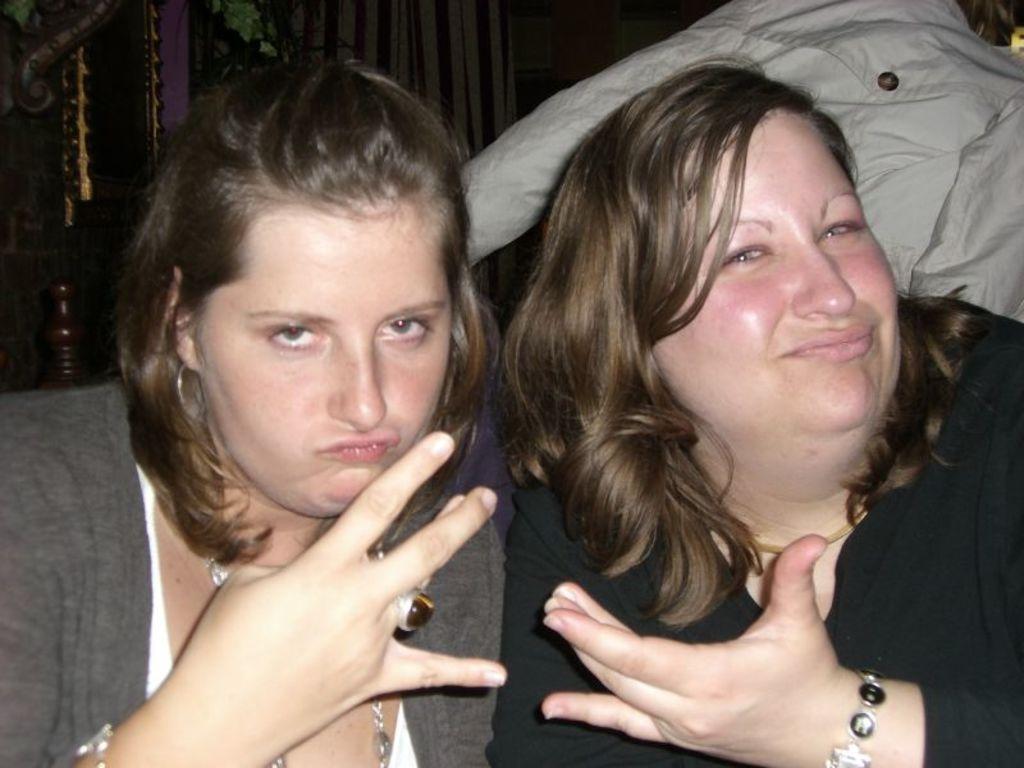In one or two sentences, can you explain what this image depicts? There are two women posing to a camera and there is a cloth. 